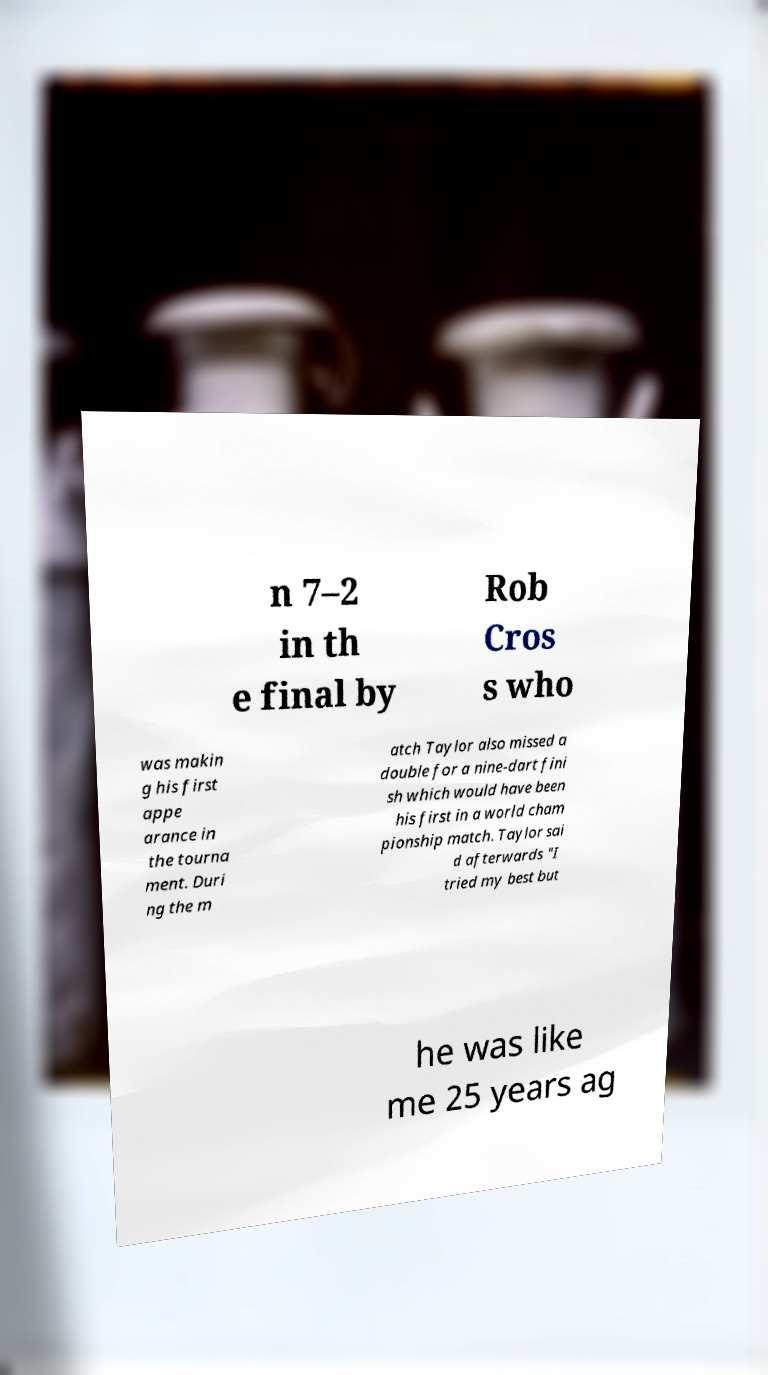Can you read and provide the text displayed in the image?This photo seems to have some interesting text. Can you extract and type it out for me? n 7–2 in th e final by Rob Cros s who was makin g his first appe arance in the tourna ment. Duri ng the m atch Taylor also missed a double for a nine-dart fini sh which would have been his first in a world cham pionship match. Taylor sai d afterwards "I tried my best but he was like me 25 years ag 